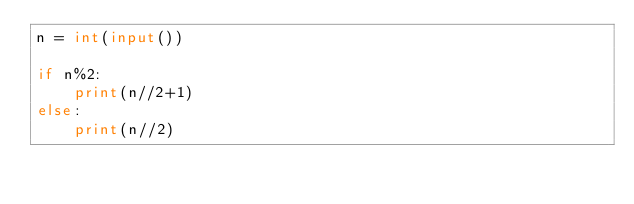Convert code to text. <code><loc_0><loc_0><loc_500><loc_500><_Python_>n = int(input())

if n%2:
    print(n//2+1)
else:
    print(n//2)
</code> 